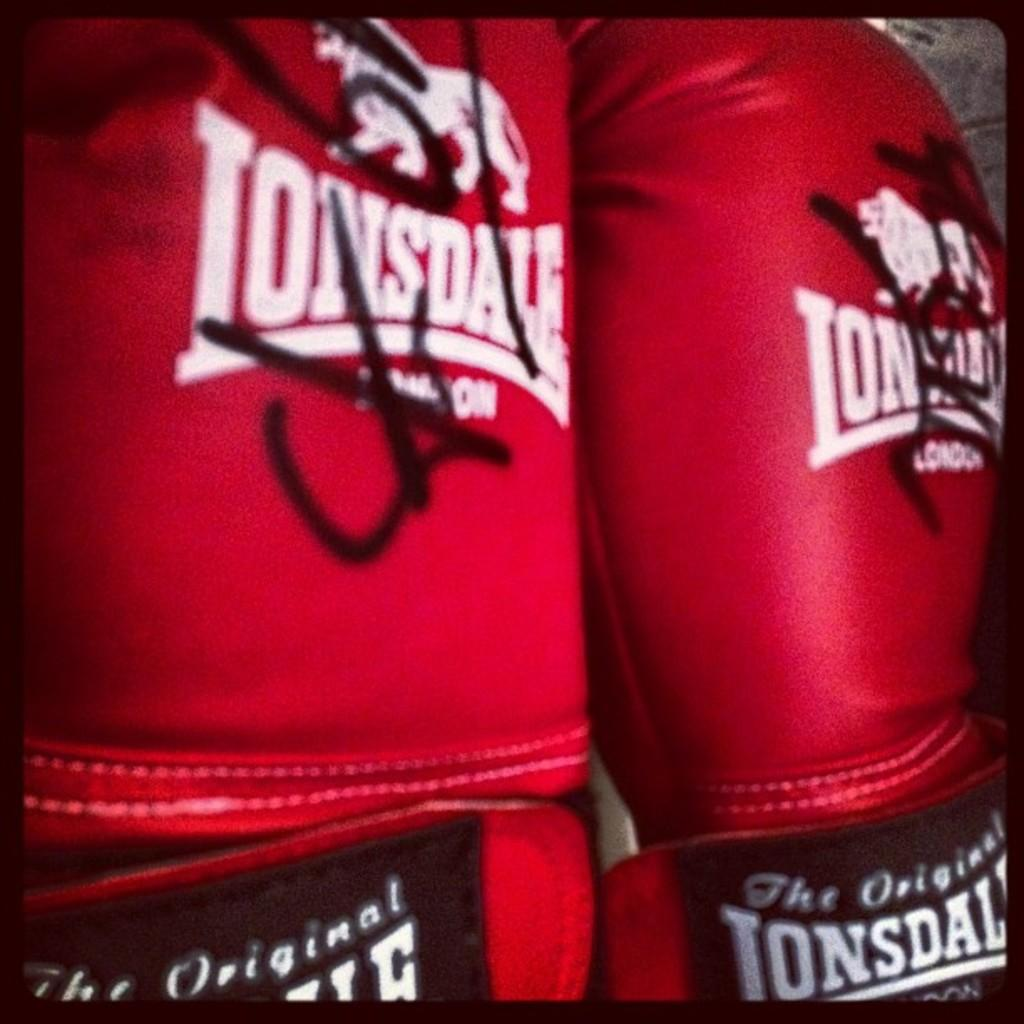What type of sports equipment is featured in the picture? There is a pair of red color boxing gloves in the picture. Can you describe any specific details about the boxing gloves? There is a logo on the boxing gloves. What type of jelly can be seen on the boxing gloves in the image? There is no jelly present on the boxing gloves in the image. 